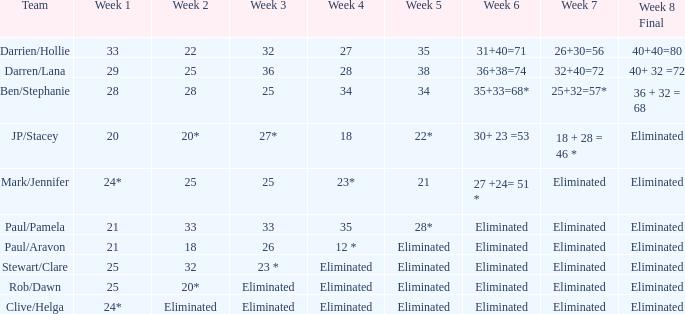Name the week 3 for team of mark/jennifer 25.0. 